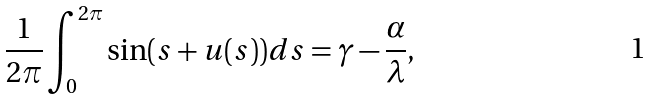Convert formula to latex. <formula><loc_0><loc_0><loc_500><loc_500>\frac { 1 } { 2 \pi } \int _ { 0 } ^ { 2 \pi } { \sin ( s + u ( s ) ) d s } = \gamma - \frac { \alpha } { \lambda } ,</formula> 